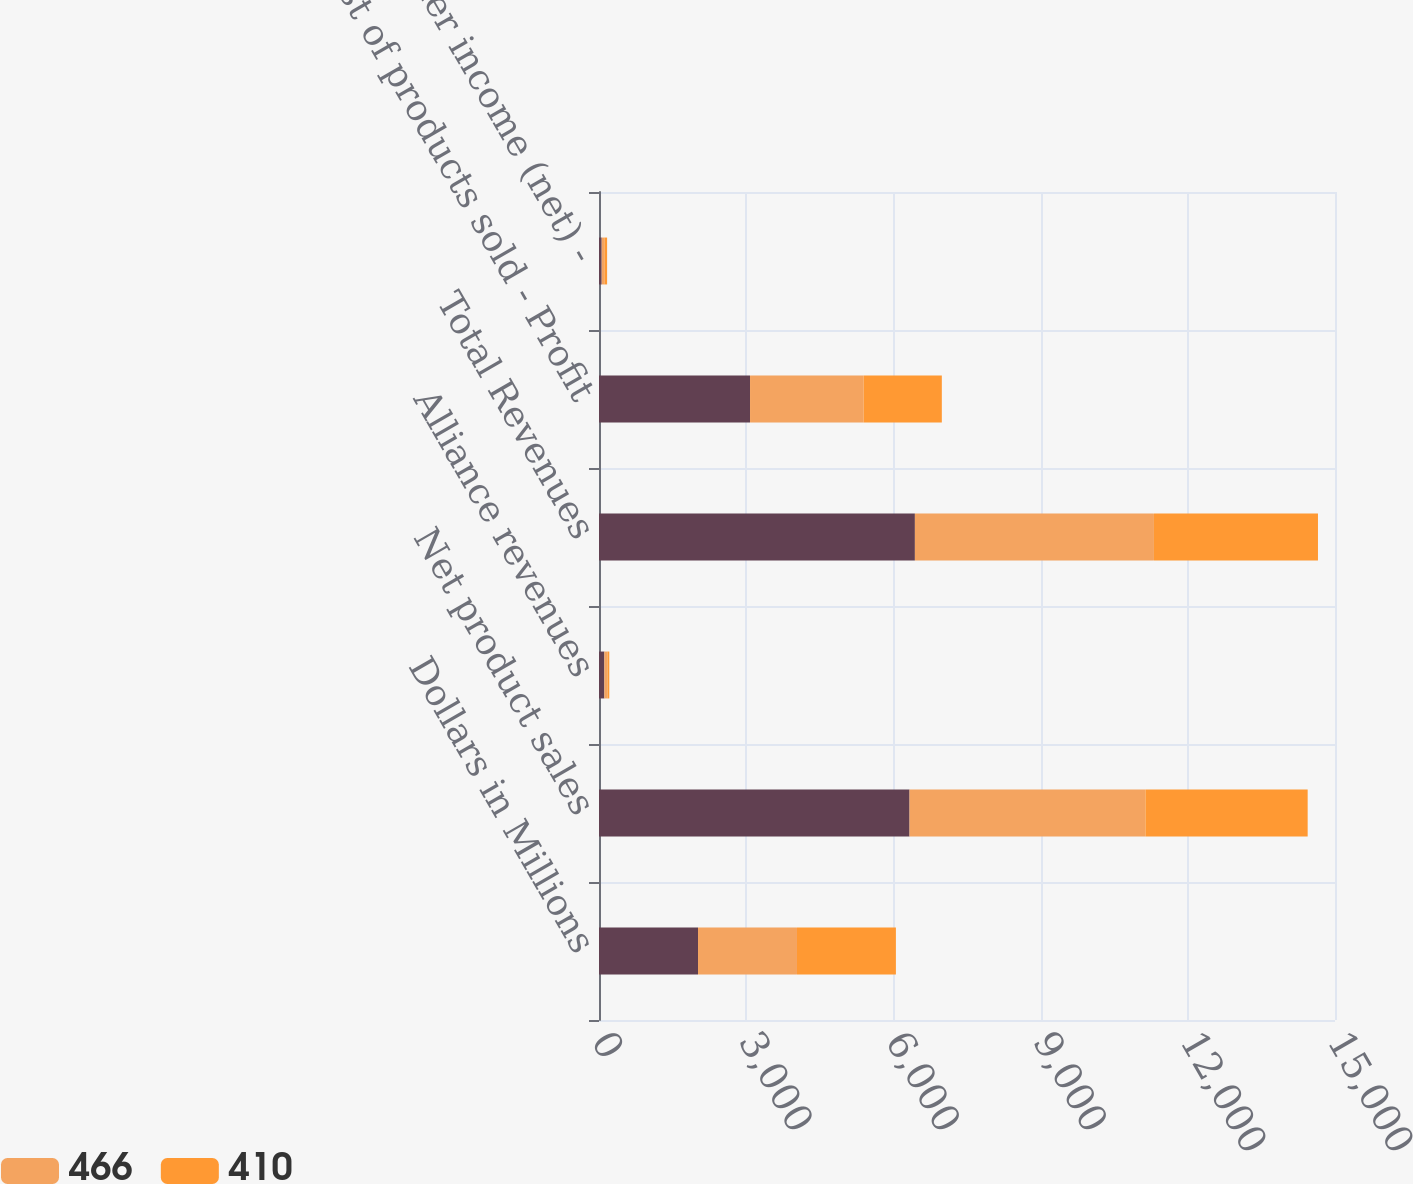Convert chart. <chart><loc_0><loc_0><loc_500><loc_500><stacked_bar_chart><ecel><fcel>Dollars in Millions<fcel>Net product sales<fcel>Alliance revenues<fcel>Total Revenues<fcel>Cost of products sold - Profit<fcel>Other income (net) -<nl><fcel>nan<fcel>2018<fcel>6329<fcel>109<fcel>6438<fcel>3078<fcel>55<nl><fcel>466<fcel>2017<fcel>4808<fcel>64<fcel>4872<fcel>2314<fcel>55<nl><fcel>410<fcel>2016<fcel>3306<fcel>37<fcel>3343<fcel>1595<fcel>55<nl></chart> 